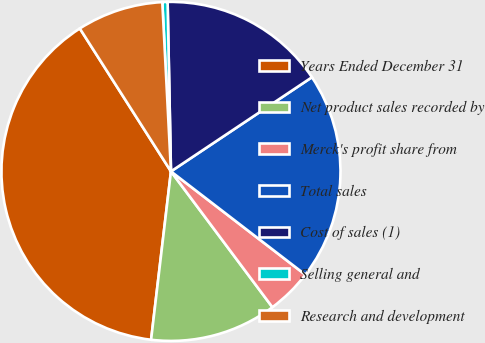Convert chart to OTSL. <chart><loc_0><loc_0><loc_500><loc_500><pie_chart><fcel>Years Ended December 31<fcel>Net product sales recorded by<fcel>Merck's profit share from<fcel>Total sales<fcel>Cost of sales (1)<fcel>Selling general and<fcel>Research and development<nl><fcel>39.09%<fcel>12.08%<fcel>4.36%<fcel>19.8%<fcel>15.94%<fcel>0.5%<fcel>8.22%<nl></chart> 